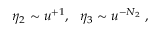<formula> <loc_0><loc_0><loc_500><loc_500>\eta _ { 2 } \sim u ^ { + 1 } , \eta _ { 3 } \sim u ^ { - N _ { 2 } } \ ,</formula> 